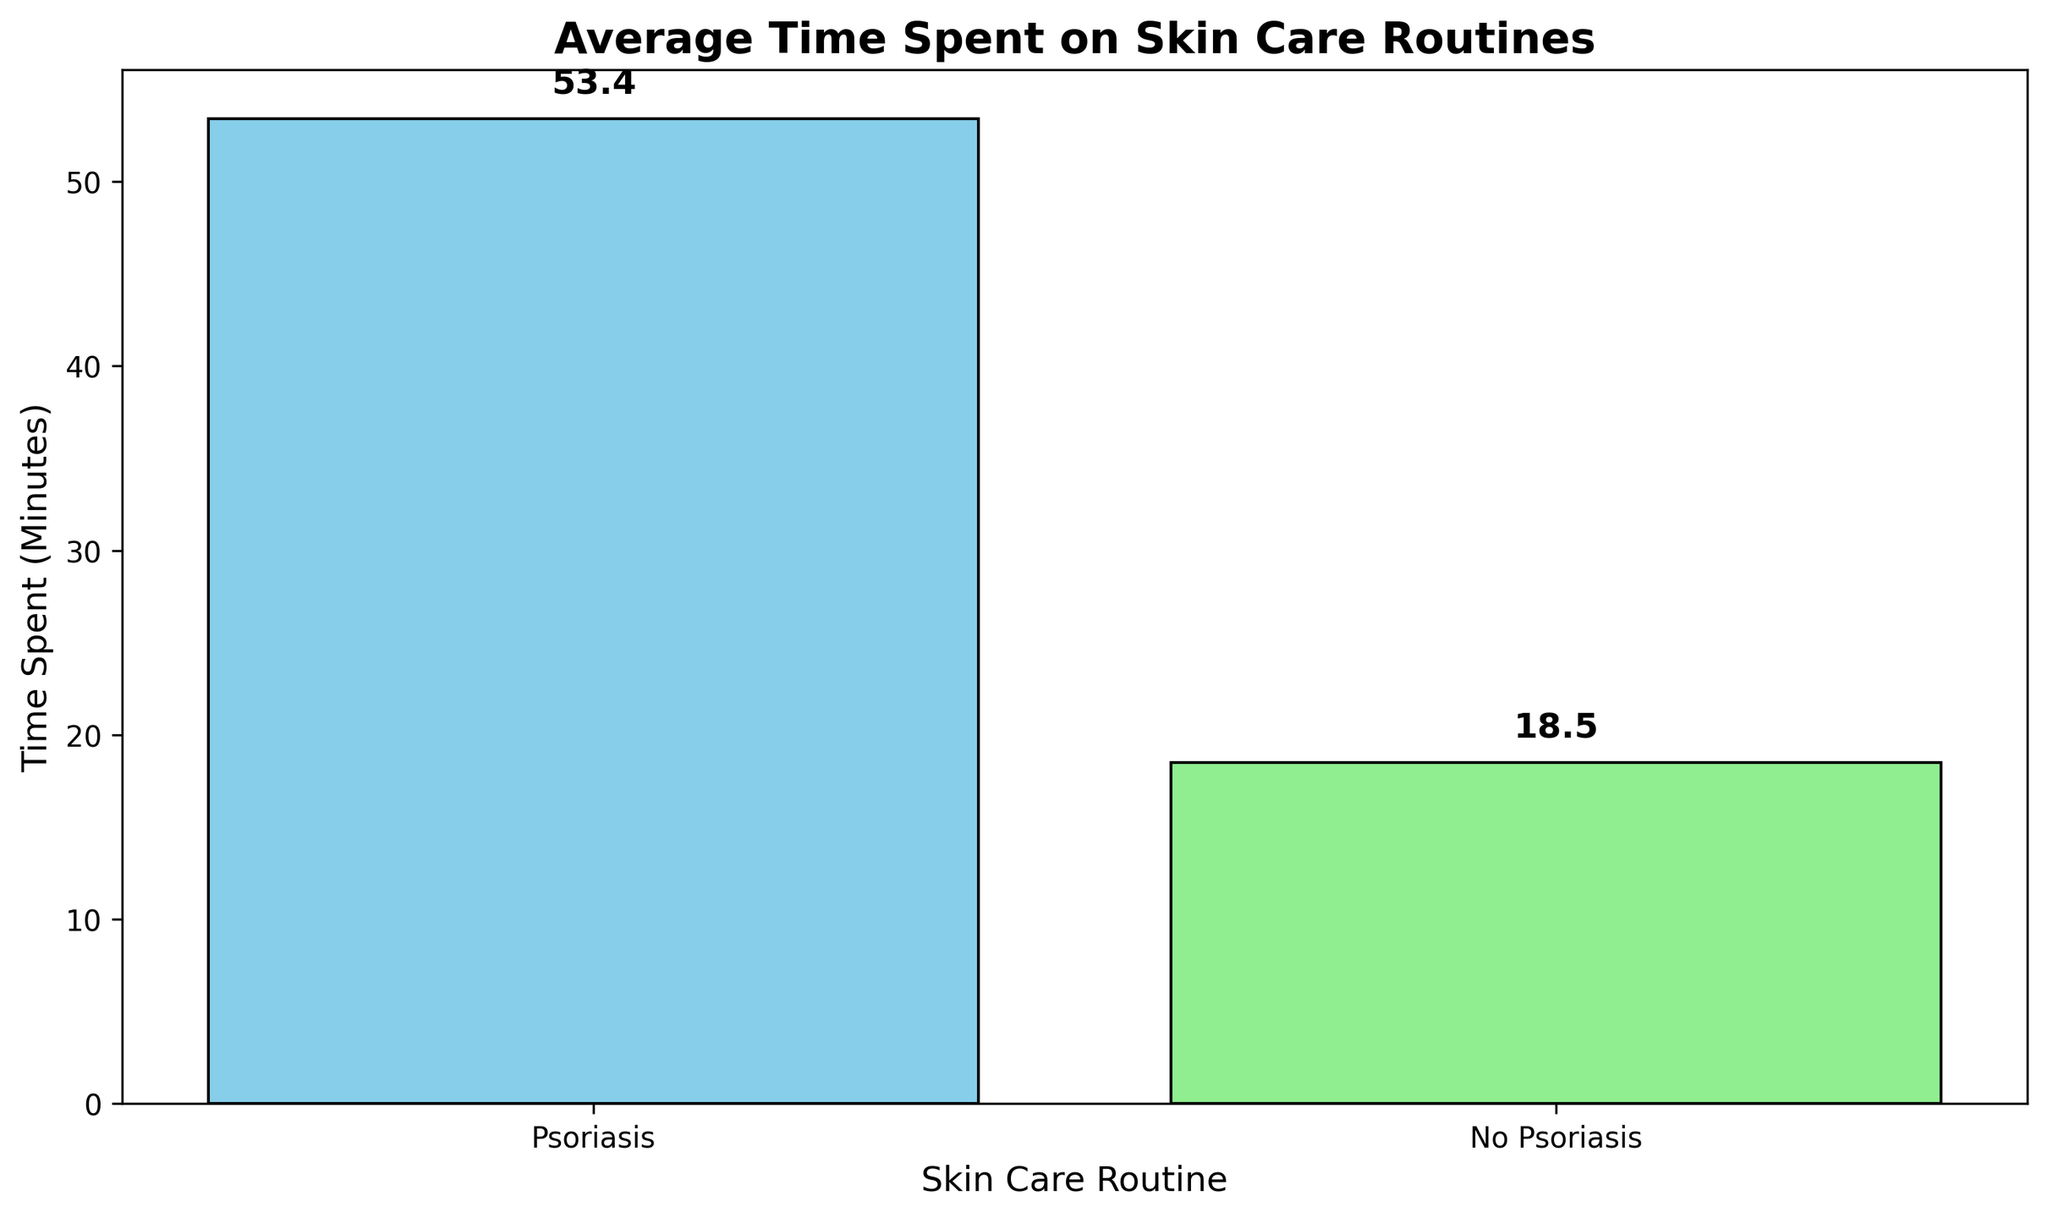What is the average time spent on skin care routines by individuals with psoriasis? The height of the bar labeled 'Psoriasis' shows the average time. According to the figure, it is approximately 53.4 minutes.
Answer: 53.4 minutes What is the average time spent on skin care routines by individuals without psoriasis? The height of the bar labeled 'No Psoriasis' shows the average time. According to the figure, it is approximately 18.5 minutes.
Answer: 18.5 minutes How much more time do individuals with psoriasis spend on skin care compared to those without? Subtract the average time spent by individuals without psoriasis (18.5 minutes) from the average time spent by individuals with psoriasis (53.4 minutes). The difference is 53.4 - 18.5 = 34.9 minutes.
Answer: 34.9 minutes Which group spends more time on skin care routines? Compare the heights of the two bars. The bar for 'Psoriasis' is taller, indicating that individuals with psoriasis spend more time.
Answer: Psoriasis By how many times is the average time spent by individuals with psoriasis greater than those without? Divide the average time for individuals with psoriasis (53.4 minutes) by that for individuals without psoriasis (18.5 minutes). The approximation is 53.4 / 18.5 ≈ 2.89.
Answer: About 2.89 times What are the colors of the bars representing individuals with and without psoriasis? The bar for individuals with psoriasis is colored sky blue, and the bar for individuals without psoriasis is light green.
Answer: Sky blue and light green What is the average difference in time spent on skin care routines between these two groups? Subtract the average time spent by individuals without psoriasis (18.5 minutes) from the average time spent by individuals with psoriasis (53.4 minutes). The difference is 34.9 minutes.
Answer: 34.9 minutes Which bar in the chart has the height closest to 50 minutes? Observe the height of the bars. The 'Psoriasis' bar has a height closest to 50 minutes.
Answer: Psoriasis What is the combined average time spent on skin care routines by both groups? (Average time for 'Psoriasis' + Average time for 'No Psoriasis') / 2. (53.4 + 18.5) / 2 = 71.9 / 2 = 35.95 minutes.
Answer: 35.95 minutes 